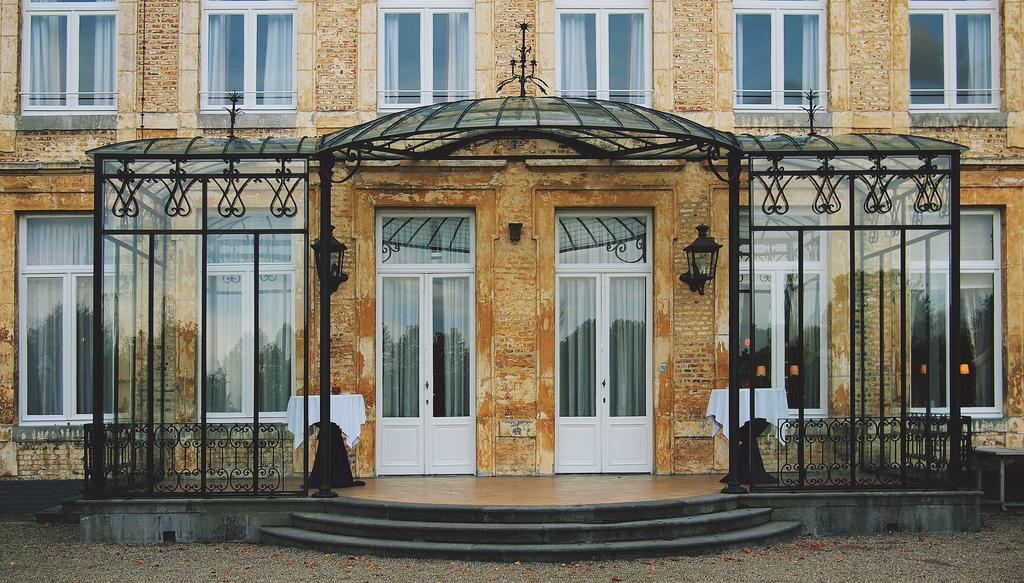What type of structure is present in the picture? There is a building in the picture. What features can be seen on the building? The building has doors and windows. What is located near the building? There is a fence in the picture. What type of window treatment is present in the picture? There are curtains in the picture. What else can be seen in the picture besides the building and its features? There are other objects in the picture. Are there any architectural elements that provide access to the building? Yes, there are steps in the picture. How many trains can be seen passing by the building in the picture? There are no trains visible in the picture. What do you believe the building is used for based on the image? The image does not provide enough information to determine the building's purpose or use. 